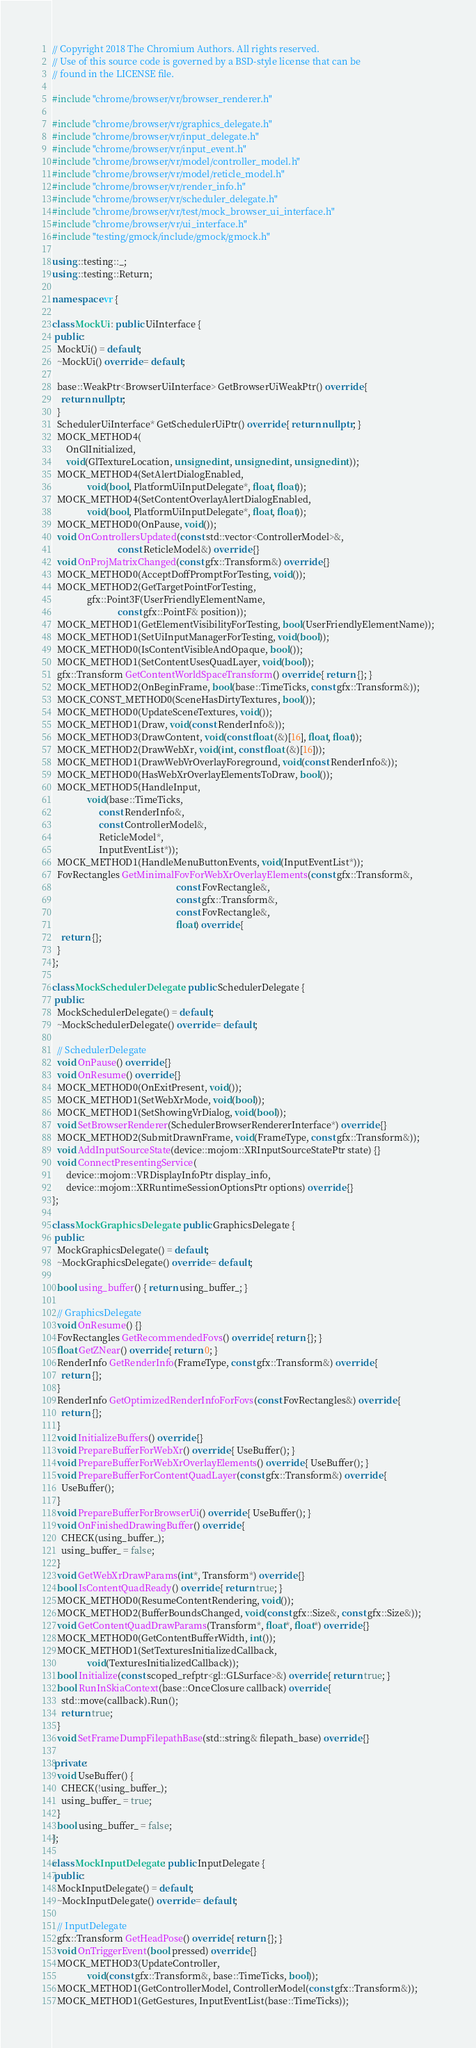Convert code to text. <code><loc_0><loc_0><loc_500><loc_500><_C++_>// Copyright 2018 The Chromium Authors. All rights reserved.
// Use of this source code is governed by a BSD-style license that can be
// found in the LICENSE file.

#include "chrome/browser/vr/browser_renderer.h"

#include "chrome/browser/vr/graphics_delegate.h"
#include "chrome/browser/vr/input_delegate.h"
#include "chrome/browser/vr/input_event.h"
#include "chrome/browser/vr/model/controller_model.h"
#include "chrome/browser/vr/model/reticle_model.h"
#include "chrome/browser/vr/render_info.h"
#include "chrome/browser/vr/scheduler_delegate.h"
#include "chrome/browser/vr/test/mock_browser_ui_interface.h"
#include "chrome/browser/vr/ui_interface.h"
#include "testing/gmock/include/gmock/gmock.h"

using ::testing::_;
using ::testing::Return;

namespace vr {

class MockUi : public UiInterface {
 public:
  MockUi() = default;
  ~MockUi() override = default;

  base::WeakPtr<BrowserUiInterface> GetBrowserUiWeakPtr() override {
    return nullptr;
  }
  SchedulerUiInterface* GetSchedulerUiPtr() override { return nullptr; }
  MOCK_METHOD4(
      OnGlInitialized,
      void(GlTextureLocation, unsigned int, unsigned int, unsigned int));
  MOCK_METHOD4(SetAlertDialogEnabled,
               void(bool, PlatformUiInputDelegate*, float, float));
  MOCK_METHOD4(SetContentOverlayAlertDialogEnabled,
               void(bool, PlatformUiInputDelegate*, float, float));
  MOCK_METHOD0(OnPause, void());
  void OnControllersUpdated(const std::vector<ControllerModel>&,
                            const ReticleModel&) override {}
  void OnProjMatrixChanged(const gfx::Transform&) override {}
  MOCK_METHOD0(AcceptDoffPromptForTesting, void());
  MOCK_METHOD2(GetTargetPointForTesting,
               gfx::Point3F(UserFriendlyElementName,
                            const gfx::PointF& position));
  MOCK_METHOD1(GetElementVisibilityForTesting, bool(UserFriendlyElementName));
  MOCK_METHOD1(SetUiInputManagerForTesting, void(bool));
  MOCK_METHOD0(IsContentVisibleAndOpaque, bool());
  MOCK_METHOD1(SetContentUsesQuadLayer, void(bool));
  gfx::Transform GetContentWorldSpaceTransform() override { return {}; }
  MOCK_METHOD2(OnBeginFrame, bool(base::TimeTicks, const gfx::Transform&));
  MOCK_CONST_METHOD0(SceneHasDirtyTextures, bool());
  MOCK_METHOD0(UpdateSceneTextures, void());
  MOCK_METHOD1(Draw, void(const RenderInfo&));
  MOCK_METHOD3(DrawContent, void(const float (&)[16], float, float));
  MOCK_METHOD2(DrawWebXr, void(int, const float (&)[16]));
  MOCK_METHOD1(DrawWebVrOverlayForeground, void(const RenderInfo&));
  MOCK_METHOD0(HasWebXrOverlayElementsToDraw, bool());
  MOCK_METHOD5(HandleInput,
               void(base::TimeTicks,
                    const RenderInfo&,
                    const ControllerModel&,
                    ReticleModel*,
                    InputEventList*));
  MOCK_METHOD1(HandleMenuButtonEvents, void(InputEventList*));
  FovRectangles GetMinimalFovForWebXrOverlayElements(const gfx::Transform&,
                                                     const FovRectangle&,
                                                     const gfx::Transform&,
                                                     const FovRectangle&,
                                                     float) override {
    return {};
  }
};

class MockSchedulerDelegate : public SchedulerDelegate {
 public:
  MockSchedulerDelegate() = default;
  ~MockSchedulerDelegate() override = default;

  // SchedulerDelegate
  void OnPause() override {}
  void OnResume() override {}
  MOCK_METHOD0(OnExitPresent, void());
  MOCK_METHOD1(SetWebXrMode, void(bool));
  MOCK_METHOD1(SetShowingVrDialog, void(bool));
  void SetBrowserRenderer(SchedulerBrowserRendererInterface*) override {}
  MOCK_METHOD2(SubmitDrawnFrame, void(FrameType, const gfx::Transform&));
  void AddInputSourceState(device::mojom::XRInputSourceStatePtr state) {}
  void ConnectPresentingService(
      device::mojom::VRDisplayInfoPtr display_info,
      device::mojom::XRRuntimeSessionOptionsPtr options) override {}
};

class MockGraphicsDelegate : public GraphicsDelegate {
 public:
  MockGraphicsDelegate() = default;
  ~MockGraphicsDelegate() override = default;

  bool using_buffer() { return using_buffer_; }

  // GraphicsDelegate
  void OnResume() {}
  FovRectangles GetRecommendedFovs() override { return {}; }
  float GetZNear() override { return 0; }
  RenderInfo GetRenderInfo(FrameType, const gfx::Transform&) override {
    return {};
  }
  RenderInfo GetOptimizedRenderInfoForFovs(const FovRectangles&) override {
    return {};
  }
  void InitializeBuffers() override {}
  void PrepareBufferForWebXr() override { UseBuffer(); }
  void PrepareBufferForWebXrOverlayElements() override { UseBuffer(); }
  void PrepareBufferForContentQuadLayer(const gfx::Transform&) override {
    UseBuffer();
  }
  void PrepareBufferForBrowserUi() override { UseBuffer(); }
  void OnFinishedDrawingBuffer() override {
    CHECK(using_buffer_);
    using_buffer_ = false;
  }
  void GetWebXrDrawParams(int*, Transform*) override {}
  bool IsContentQuadReady() override { return true; }
  MOCK_METHOD0(ResumeContentRendering, void());
  MOCK_METHOD2(BufferBoundsChanged, void(const gfx::Size&, const gfx::Size&));
  void GetContentQuadDrawParams(Transform*, float*, float*) override {}
  MOCK_METHOD0(GetContentBufferWidth, int());
  MOCK_METHOD1(SetTexturesInitializedCallback,
               void(TexturesInitializedCallback));
  bool Initialize(const scoped_refptr<gl::GLSurface>&) override { return true; }
  bool RunInSkiaContext(base::OnceClosure callback) override {
    std::move(callback).Run();
    return true;
  }
  void SetFrameDumpFilepathBase(std::string& filepath_base) override {}

 private:
  void UseBuffer() {
    CHECK(!using_buffer_);
    using_buffer_ = true;
  }
  bool using_buffer_ = false;
};

class MockInputDelegate : public InputDelegate {
 public:
  MockInputDelegate() = default;
  ~MockInputDelegate() override = default;

  // InputDelegate
  gfx::Transform GetHeadPose() override { return {}; }
  void OnTriggerEvent(bool pressed) override {}
  MOCK_METHOD3(UpdateController,
               void(const gfx::Transform&, base::TimeTicks, bool));
  MOCK_METHOD1(GetControllerModel, ControllerModel(const gfx::Transform&));
  MOCK_METHOD1(GetGestures, InputEventList(base::TimeTicks));</code> 